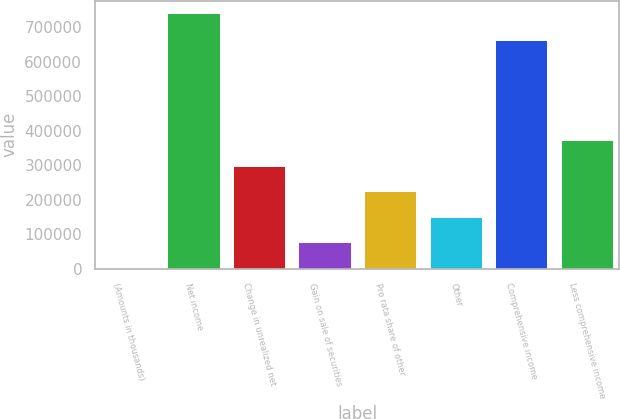Convert chart to OTSL. <chart><loc_0><loc_0><loc_500><loc_500><bar_chart><fcel>(Amounts in thousands)<fcel>Net income<fcel>Change in unrealized net<fcel>Gain on sale of securities<fcel>Pro rata share of other<fcel>Other<fcel>Comprehensive income<fcel>Less comprehensive income<nl><fcel>2011<fcel>740000<fcel>297425<fcel>75864.6<fcel>223572<fcel>149718<fcel>662578<fcel>371279<nl></chart> 